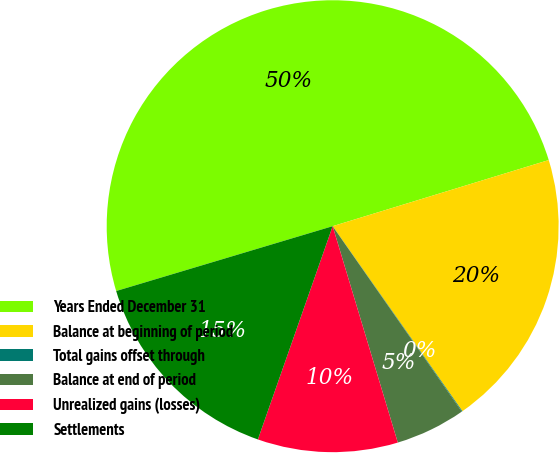<chart> <loc_0><loc_0><loc_500><loc_500><pie_chart><fcel>Years Ended December 31<fcel>Balance at beginning of period<fcel>Total gains offset through<fcel>Balance at end of period<fcel>Unrealized gains (losses)<fcel>Settlements<nl><fcel>49.9%<fcel>19.99%<fcel>0.05%<fcel>5.03%<fcel>10.02%<fcel>15.0%<nl></chart> 